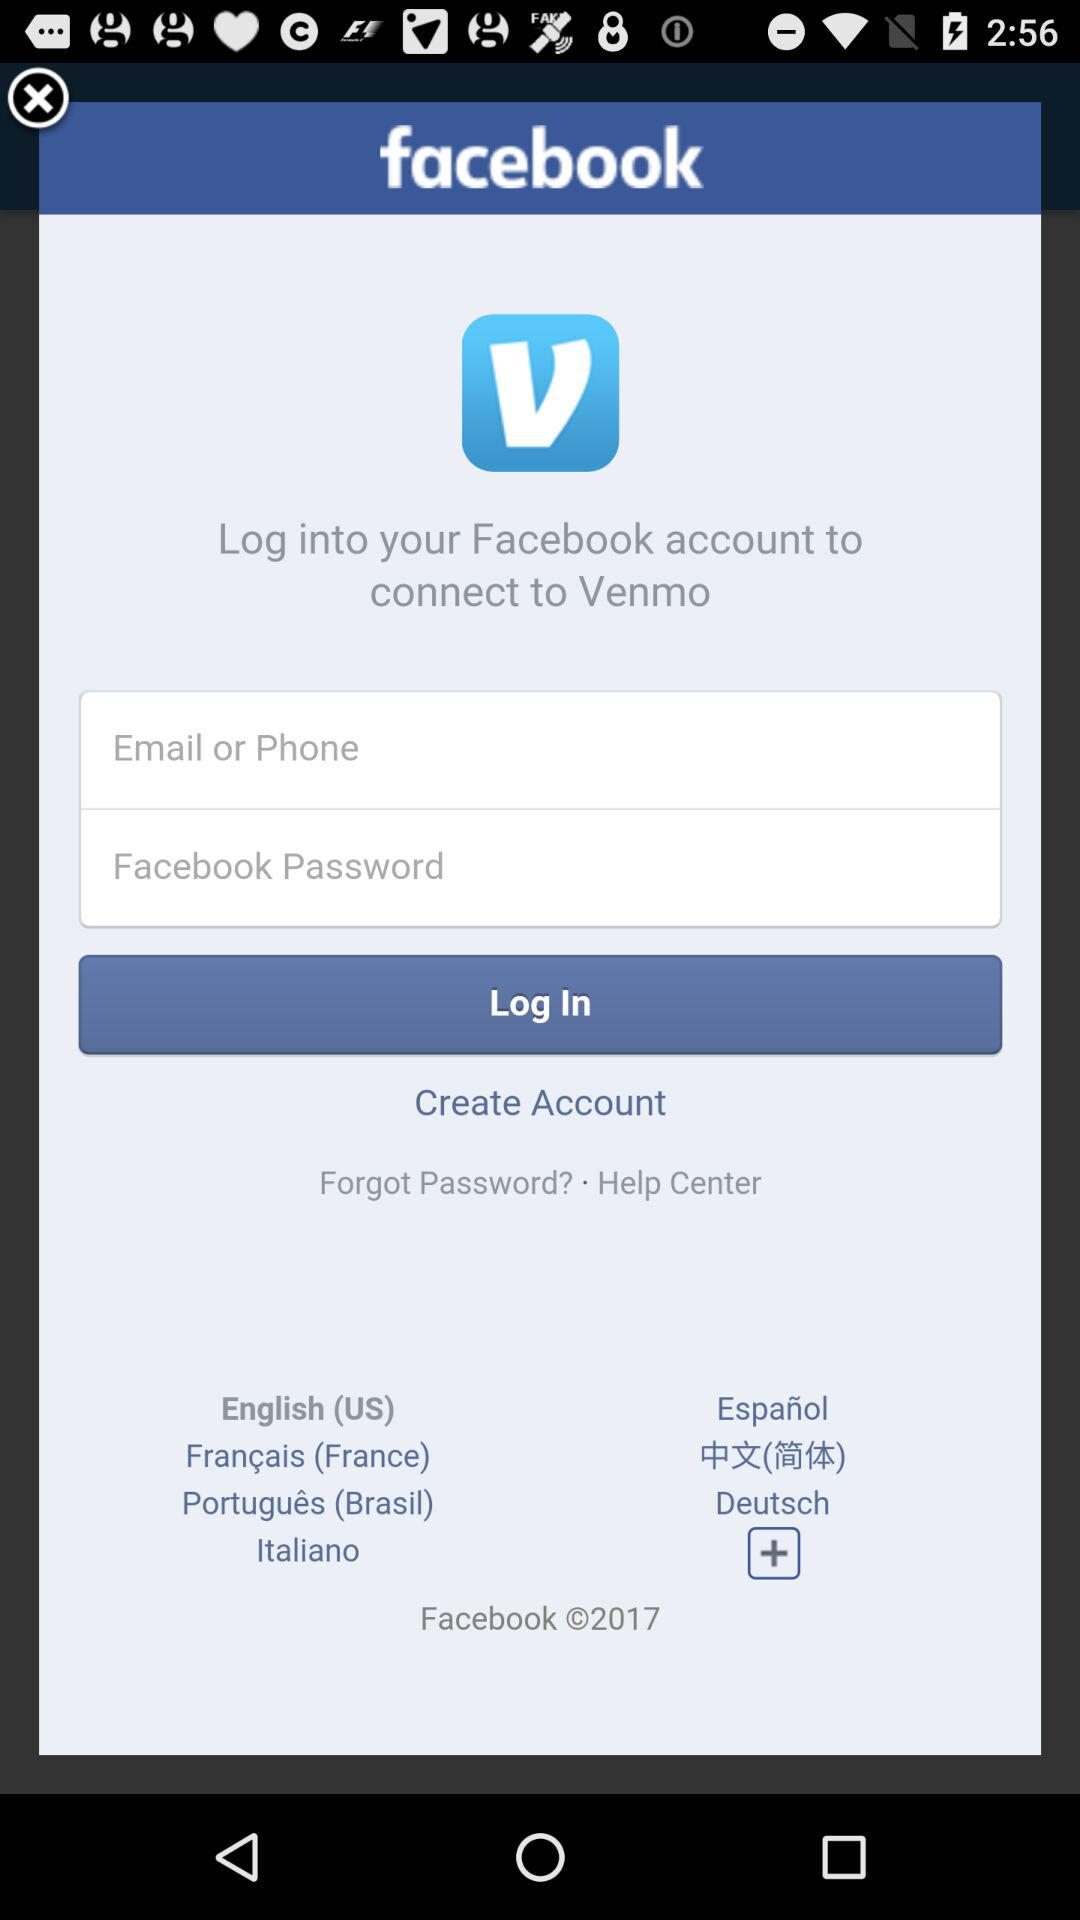Through what application can a user log in with? The application that a user can login with is Facebook. 